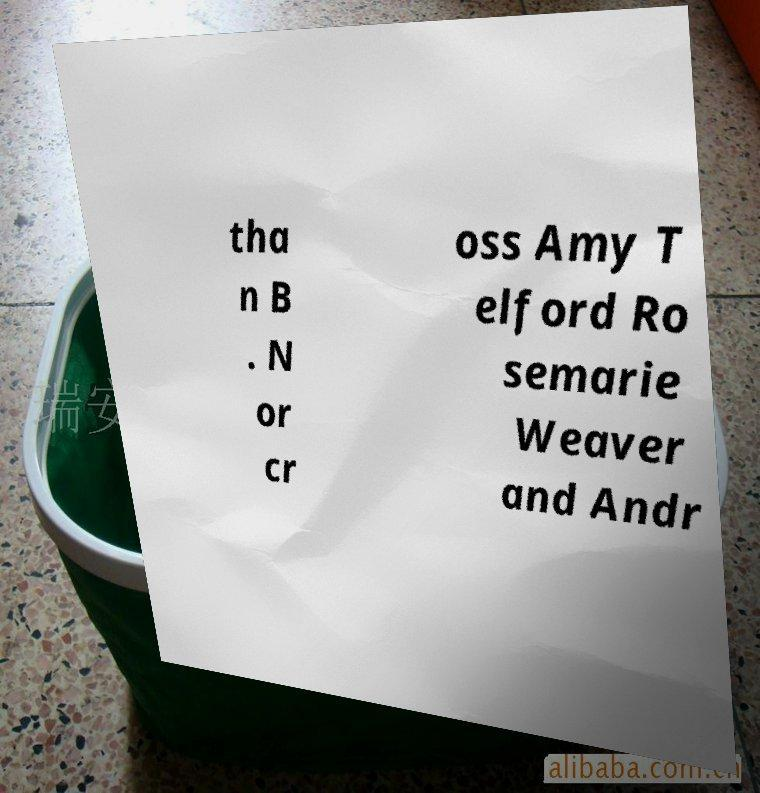What messages or text are displayed in this image? I need them in a readable, typed format. tha n B . N or cr oss Amy T elford Ro semarie Weaver and Andr 